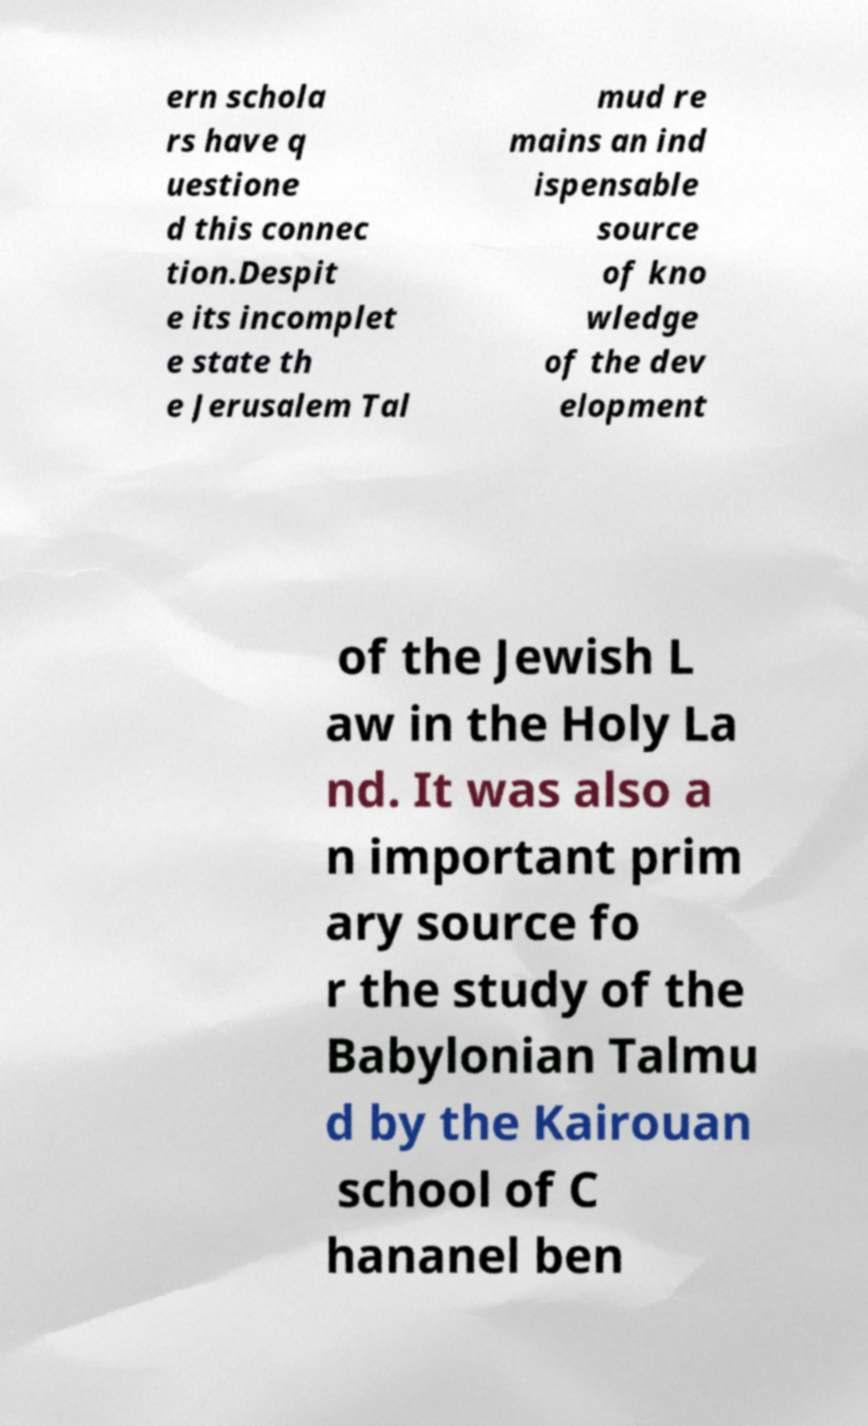Please identify and transcribe the text found in this image. ern schola rs have q uestione d this connec tion.Despit e its incomplet e state th e Jerusalem Tal mud re mains an ind ispensable source of kno wledge of the dev elopment of the Jewish L aw in the Holy La nd. It was also a n important prim ary source fo r the study of the Babylonian Talmu d by the Kairouan school of C hananel ben 